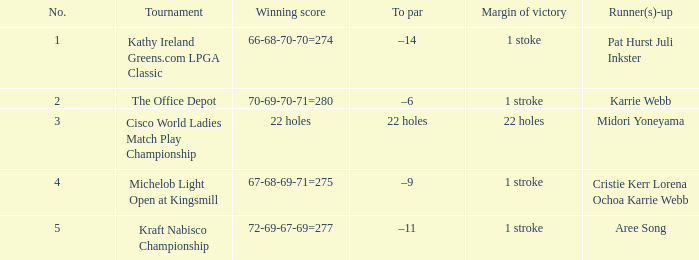Where is the margin of victory dated mar 28, 2004? 1 stroke. 